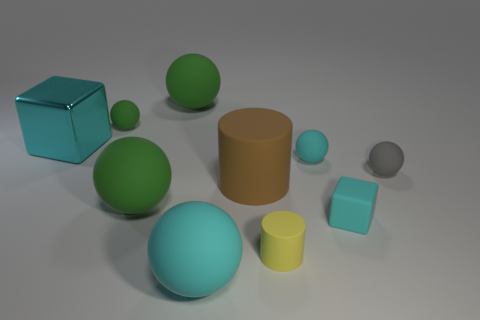How big is the brown rubber cylinder?
Your response must be concise. Large. There is a cylinder that is in front of the tiny cyan matte cube; what size is it?
Ensure brevity in your answer.  Small. Does the green matte object that is in front of the metallic object have the same size as the tiny gray object?
Your answer should be very brief. No. Are there any other things of the same color as the shiny cube?
Keep it short and to the point. Yes. The small green thing is what shape?
Your response must be concise. Sphere. What number of small rubber things are both to the right of the tiny yellow matte thing and behind the big matte cylinder?
Ensure brevity in your answer.  2. Does the large metal object have the same color as the tiny matte cube?
Your answer should be compact. Yes. What material is the small cyan object that is the same shape as the big cyan matte object?
Offer a very short reply. Rubber. Is there anything else that has the same material as the large cylinder?
Make the answer very short. Yes. Is the number of big matte cylinders that are left of the big cyan metallic block the same as the number of big matte cylinders in front of the yellow matte cylinder?
Provide a short and direct response. Yes. 